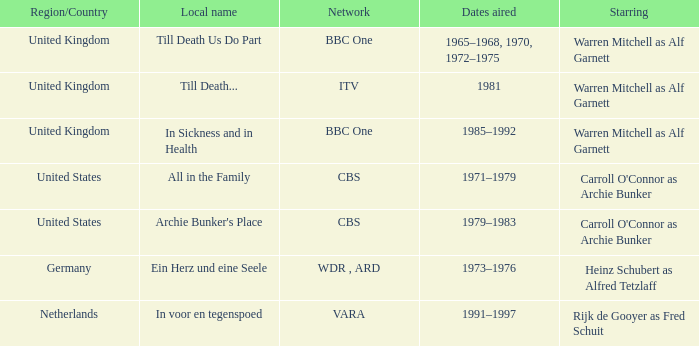What is the local name for the episodes that aired in 1981? Till Death... 